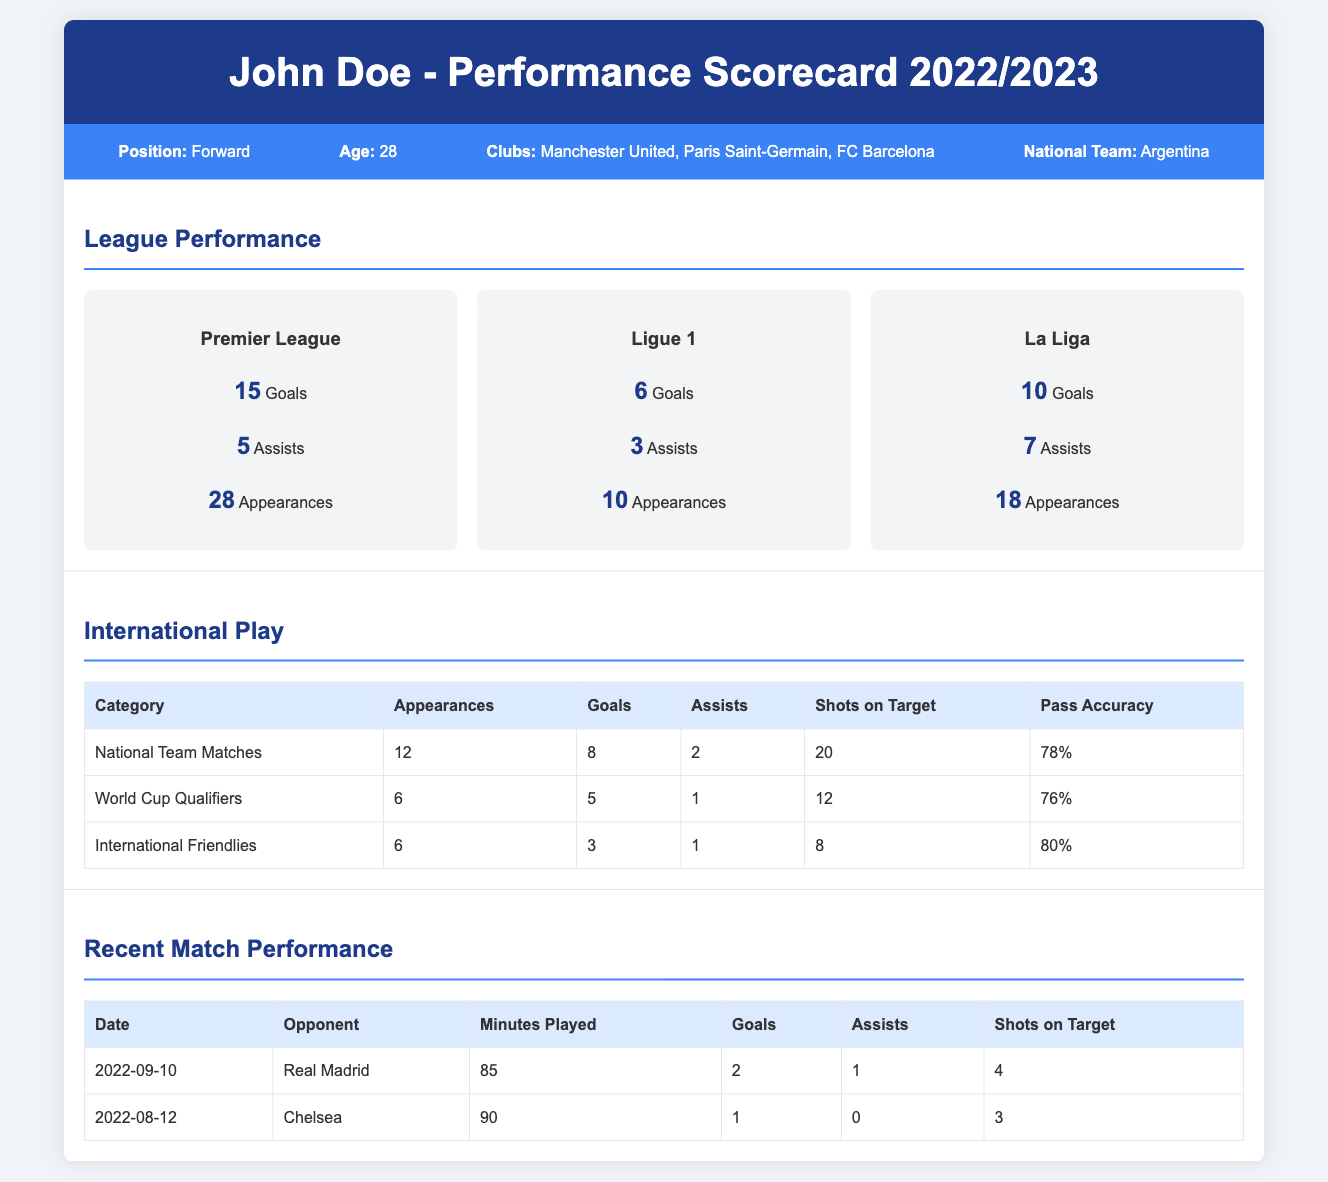What position does John Doe play? The document states that John Doe's position is Forward.
Answer: Forward How many goals did John Doe score in the Premier League? The Premier League section lists that he scored 15 goals.
Answer: 15 What is John Doe's pass accuracy in International Friendlies? The International Play table shows a pass accuracy of 80% for International Friendlies.
Answer: 80% How many appearances did John Doe make in Ligue 1? The Ligue 1 statistics indicate that he made 10 appearances.
Answer: 10 What was John Doe's total goals scored for the National Team? The International Play section indicates he scored 8 goals in National Team Matches.
Answer: 8 How many assists did John Doe provide in La Liga? The La Liga section specifies that he had 7 assists.
Answer: 7 What was the date of the match against Chelsea? The Recent Match Performance table lists the match against Chelsea as occurring on 2022-08-12.
Answer: 2022-08-12 How many shots on target did John Doe have in the match against Real Madrid? The statistics for the match against Real Madrid indicate he had 4 shots on target.
Answer: 4 Which club did John Doe play for during the 2022/2023 season? The player information section lists Manchester United, Paris Saint-Germain, and FC Barcelona as clubs he played for.
Answer: Manchester United, Paris Saint-Germain, FC Barcelona 